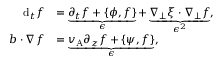Convert formula to latex. <formula><loc_0><loc_0><loc_500><loc_500>\begin{array} { r l } { d _ { t } f } & { = \underbrace { \partial _ { t } f + \{ \phi , f \} } _ { \epsilon } + \underbrace { \nabla _ { \perp } \xi \cdot \nabla _ { \perp } f } _ { \epsilon ^ { 2 } } , } \\ { b \cdot \nabla f } & { = \underbrace { v _ { A } \partial _ { z } f + \{ \psi , f \} } _ { \epsilon } , } \end{array}</formula> 